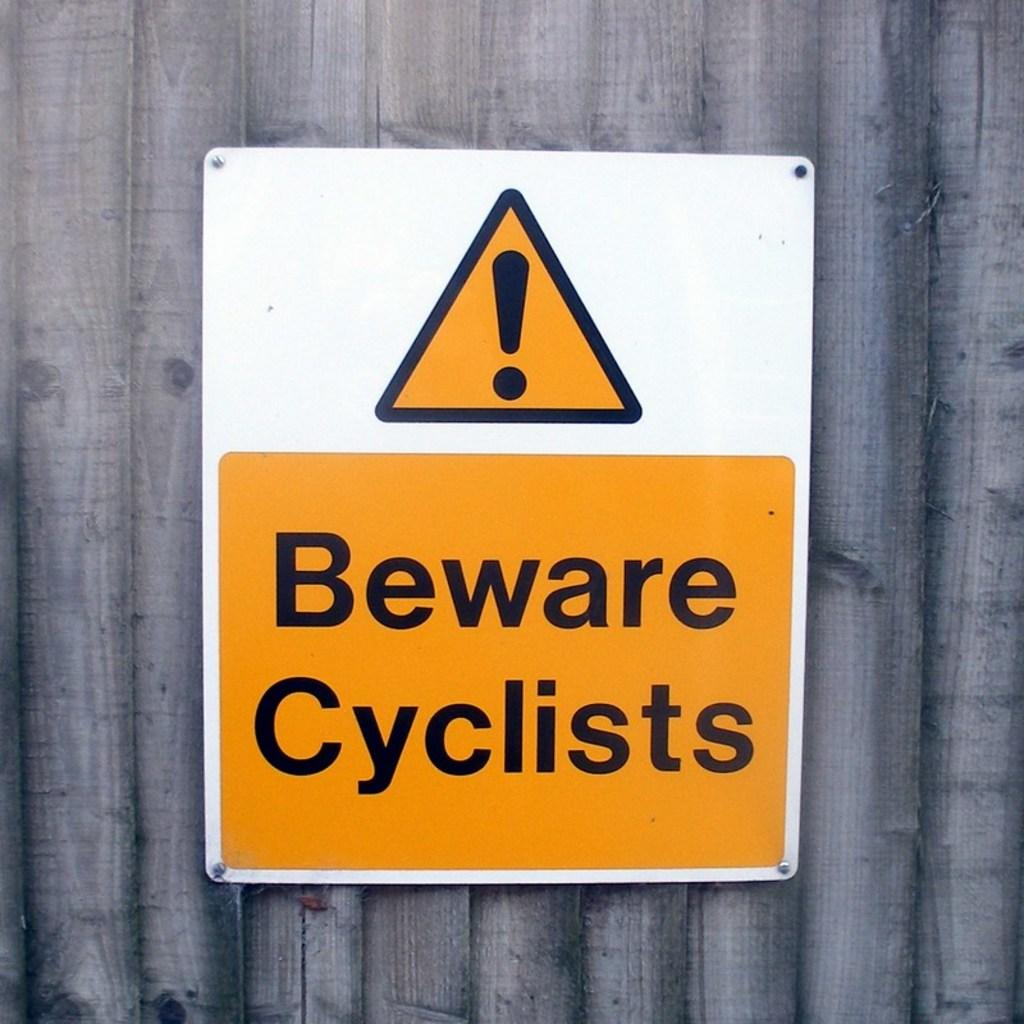<image>
Create a compact narrative representing the image presented. Yellow and white sign which says "Beware Cyclists". 